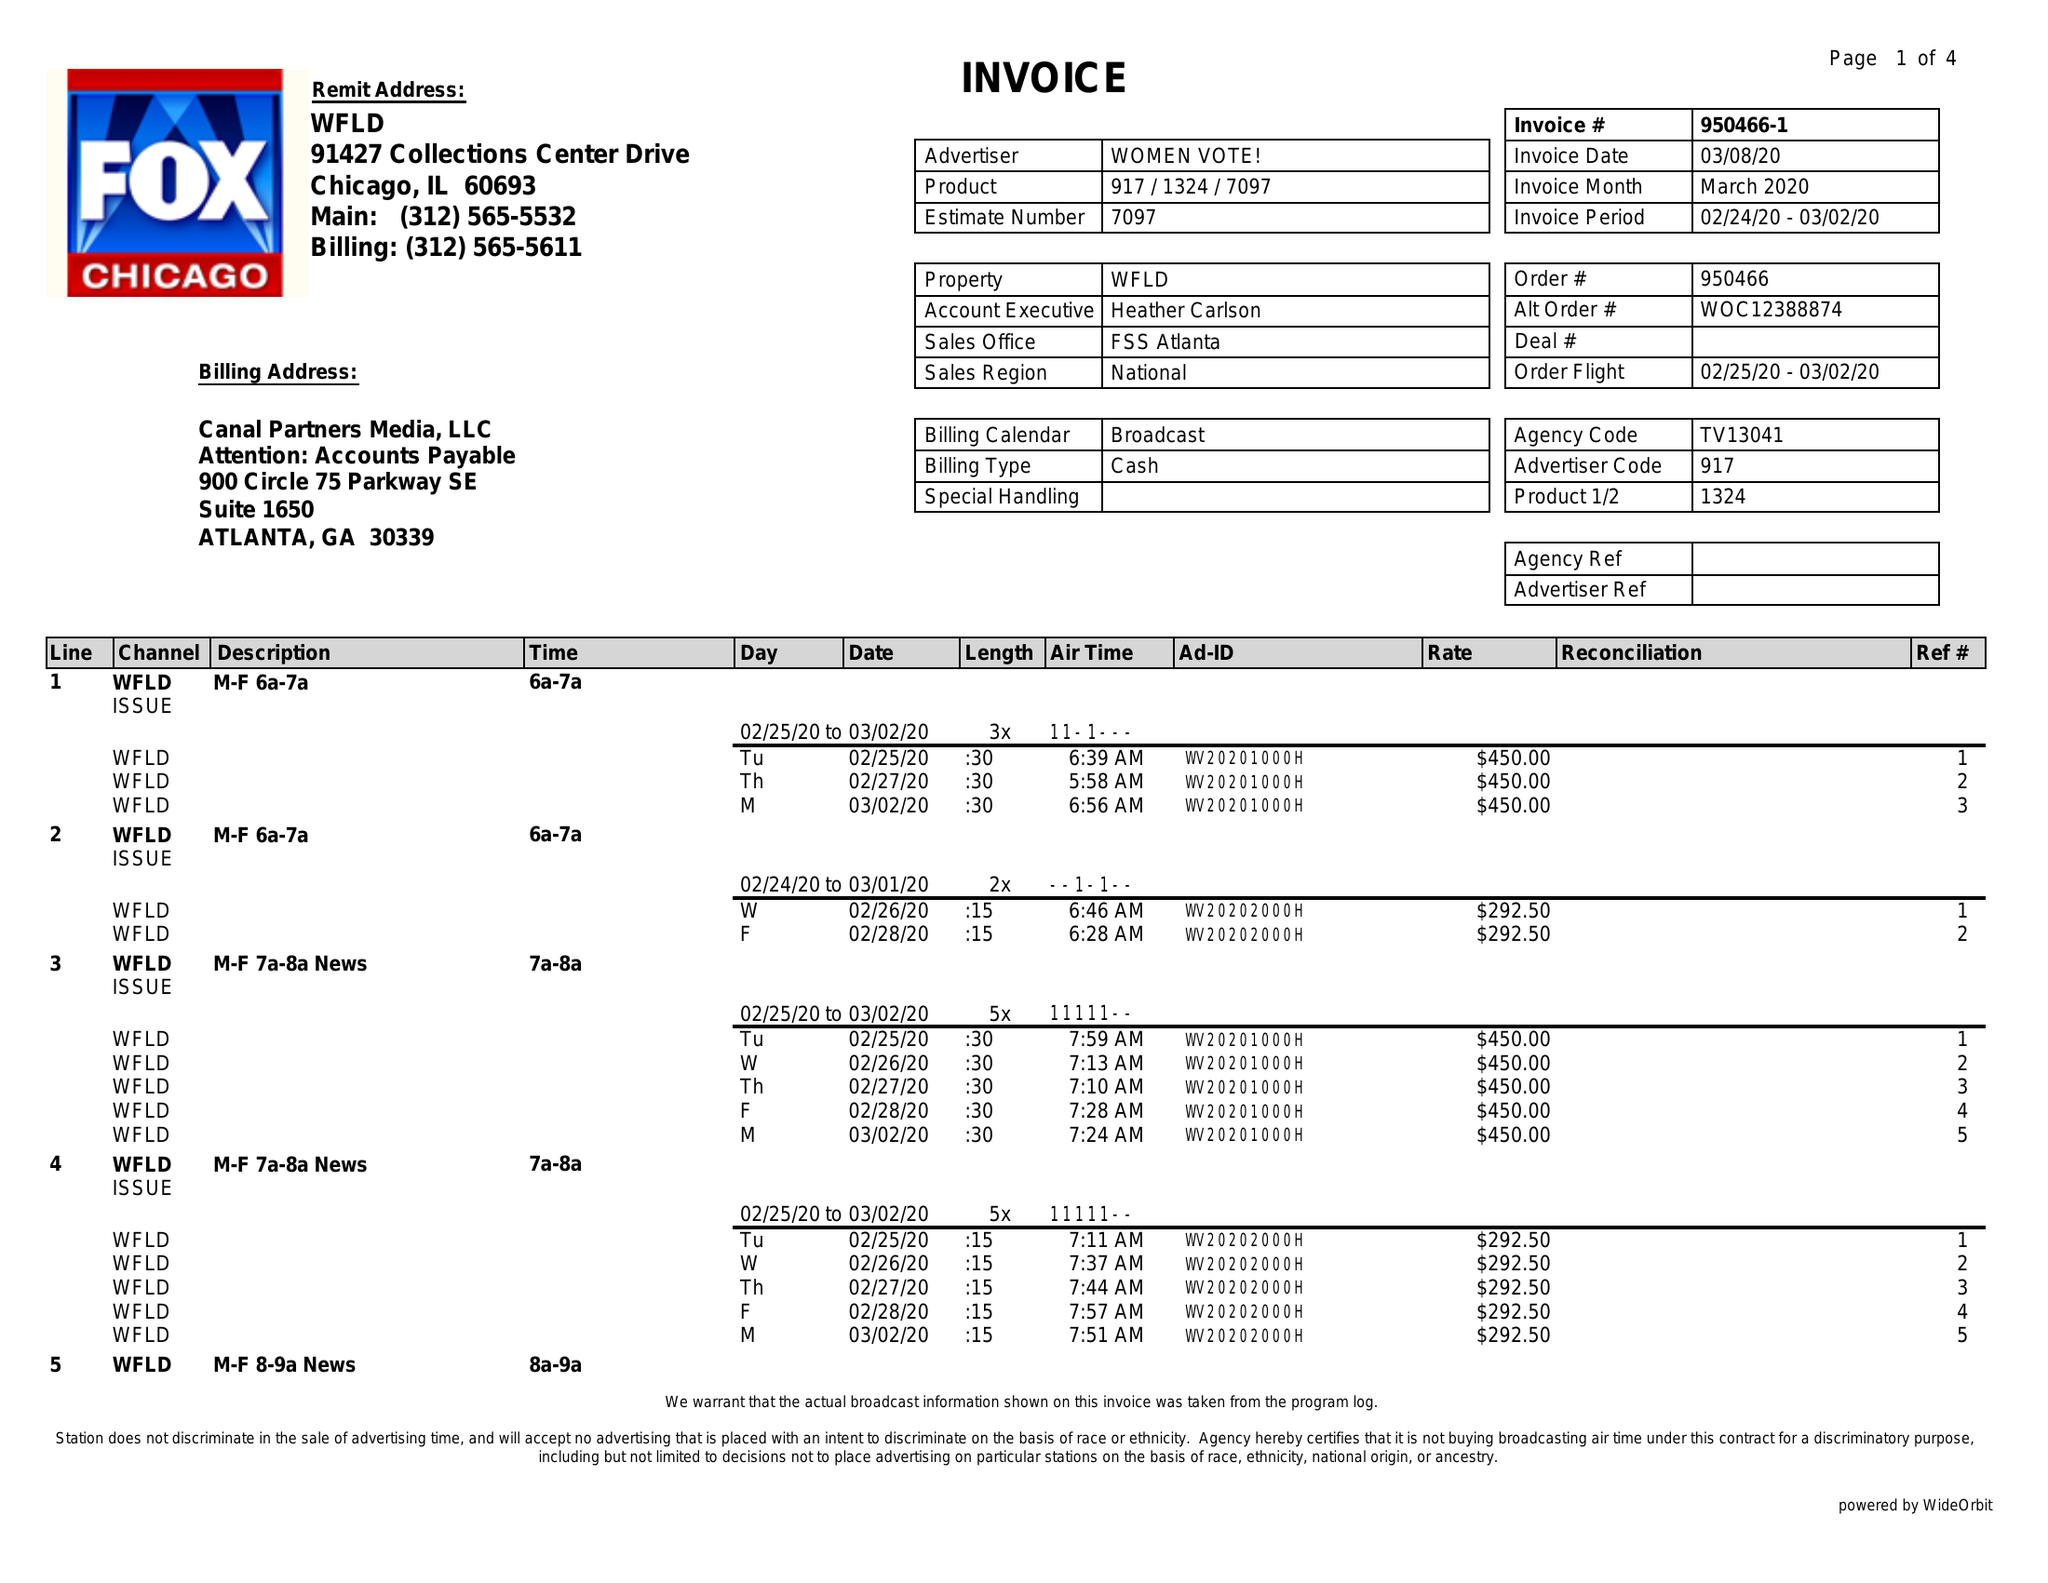What is the value for the gross_amount?
Answer the question using a single word or phrase. 19462.50 